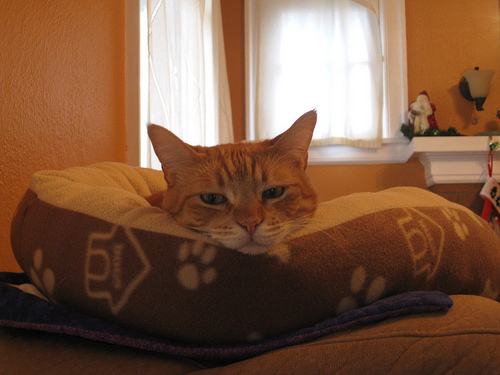<image>
Is the yellow cat next to the pet bed? No. The yellow cat is not positioned next to the pet bed. They are located in different areas of the scene. Is the cat under the screen? No. The cat is not positioned under the screen. The vertical relationship between these objects is different. Is the cat above the bed? No. The cat is not positioned above the bed. The vertical arrangement shows a different relationship. 